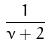<formula> <loc_0><loc_0><loc_500><loc_500>\frac { 1 } { \nu + 2 }</formula> 